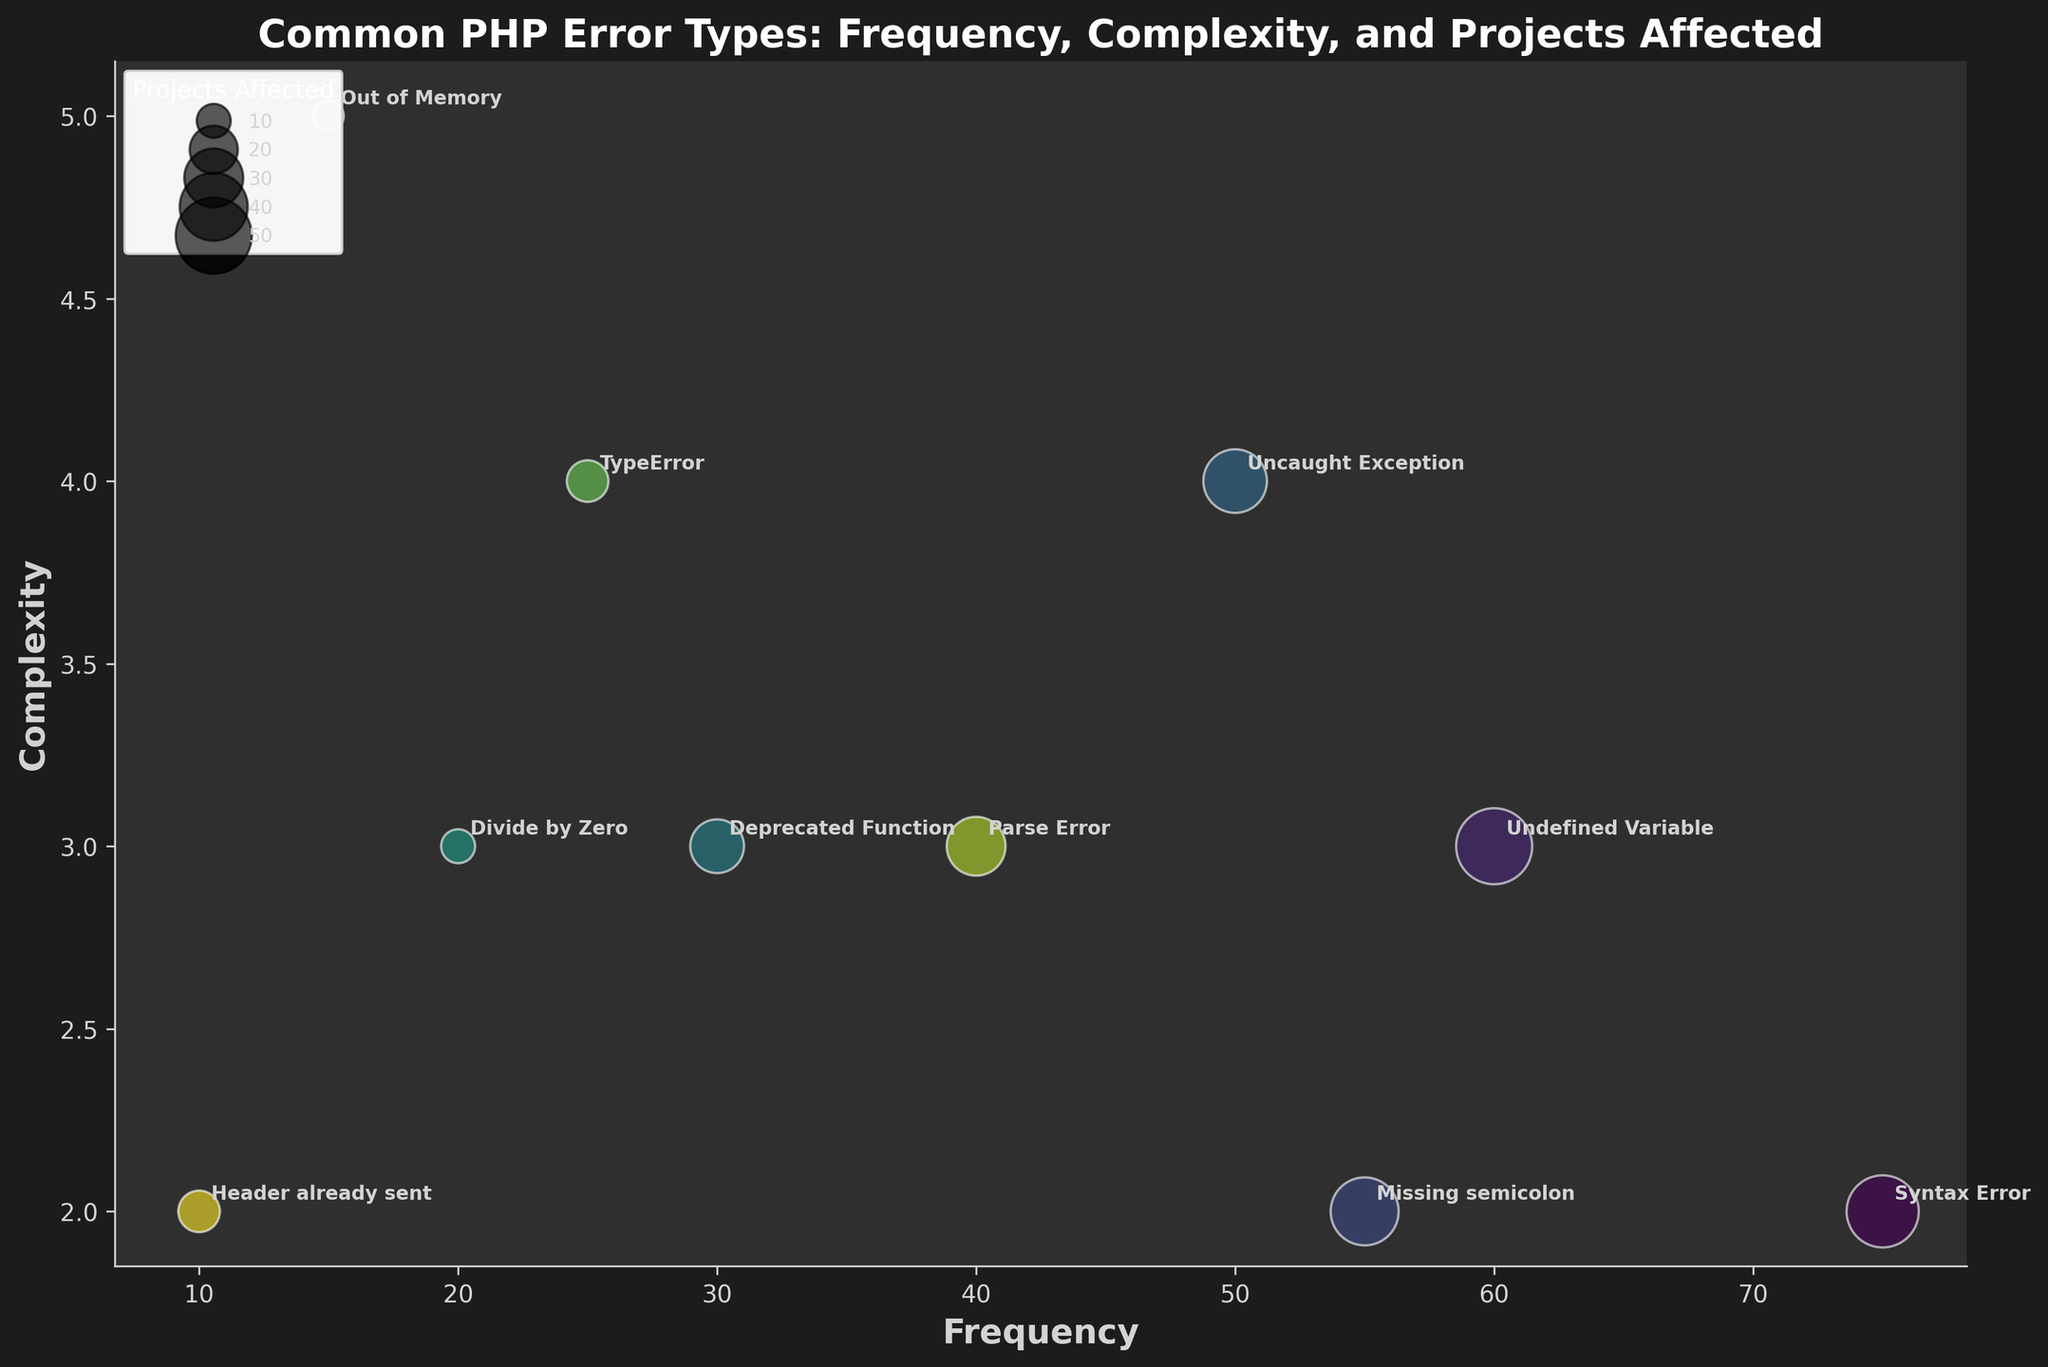What is the title of the figure? The title provides an overview of what the figure is representing. It is usually placed at the top of the chart.
Answer: Common PHP Error Types: Frequency, Complexity, and Projects Affected Which error type has the highest frequency? The error type with the highest frequency is the one represented by the bubble farthest to the right along the X-axis.
Answer: Syntax Error Which error type affects the most projects? The error type affecting the most projects will have the largest bubble size.
Answer: Undefined Variable What's the complexity of the 'Out of Memory' error type? The Y-axis indicates complexity, so find the Y-coordinate of the 'Out of Memory' bubble.
Answer: 5 How many projects are affected by 'Divide by Zero' errors? Look at the size of the 'Divide by Zero' bubble and refer to the legend for accurate size interpretation.
Answer: 10 Which error type has a frequency of 60 and how complex is it? Find the bubble located at X=60 and read off its Y-coordinate for complexity.
Answer: Undefined Variable, 3 Compare the complexity and frequency of 'Parse Error' and 'TypeError'. Which has higher values? Locate the 'Parse Error' and 'TypeError' bubbles. Compare their X and Y coordinates for frequency and complexity respectively.
Answer: Parse Error has higher frequency, TypeError has higher complexity What color is used for 'Deprecated Function'? Identify the bubble labeled 'Deprecated Function' and observe its color on the chart.
Answer: A shade of viridis (dark green) Which error types have a frequency of 55 or more? Locate and list all bubbles that are at X=55 or beyond along the X-axis.
Answer: Syntax Error, Undefined Variable, Missing semicolon What's the average complexity of all error types shown? Sum the complexity values of all error types and divide by the number of error types.
Answer: (2 + 3 + 2 + 4 + 3 + 3 + 5 + 4 + 3 + 2) / 10 = 3.1 